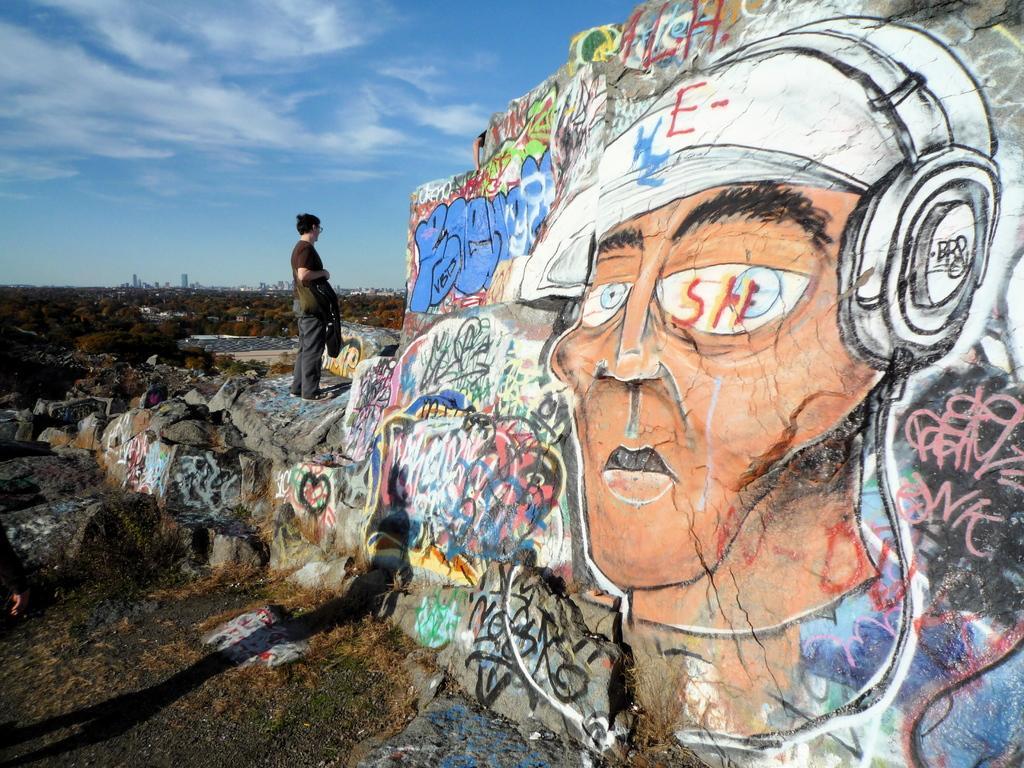How would you summarize this image in a sentence or two? This is the man standing on the rock. This looks like a painting on the wall. These are the rocks. I can see the trees. In the background, these look like buildings. Here is the shadow of a person standing. 